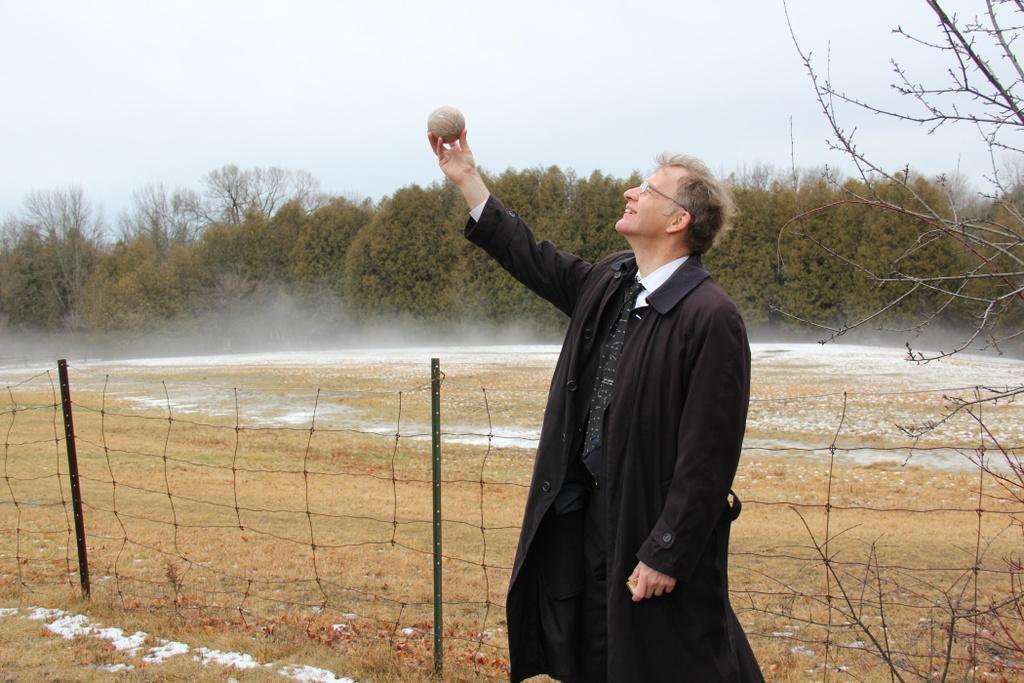How would you summarize this image in a sentence or two? Here a man is standing, he wore a black color coat, tie behind him there are green trees. At the top it's a sky. 